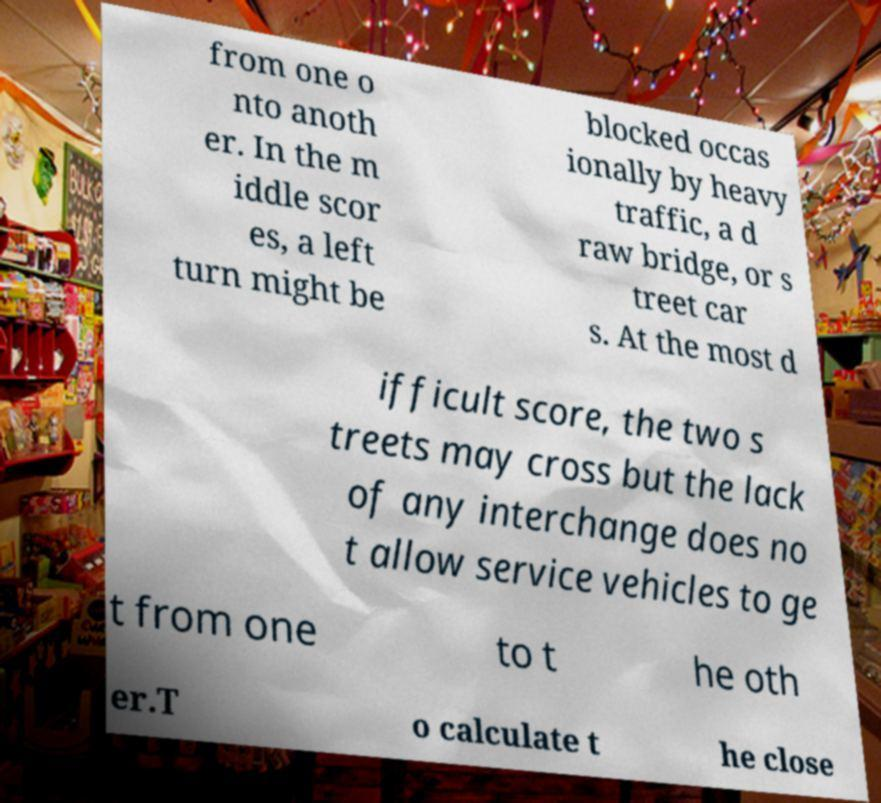There's text embedded in this image that I need extracted. Can you transcribe it verbatim? from one o nto anoth er. In the m iddle scor es, a left turn might be blocked occas ionally by heavy traffic, a d raw bridge, or s treet car s. At the most d ifficult score, the two s treets may cross but the lack of any interchange does no t allow service vehicles to ge t from one to t he oth er.T o calculate t he close 